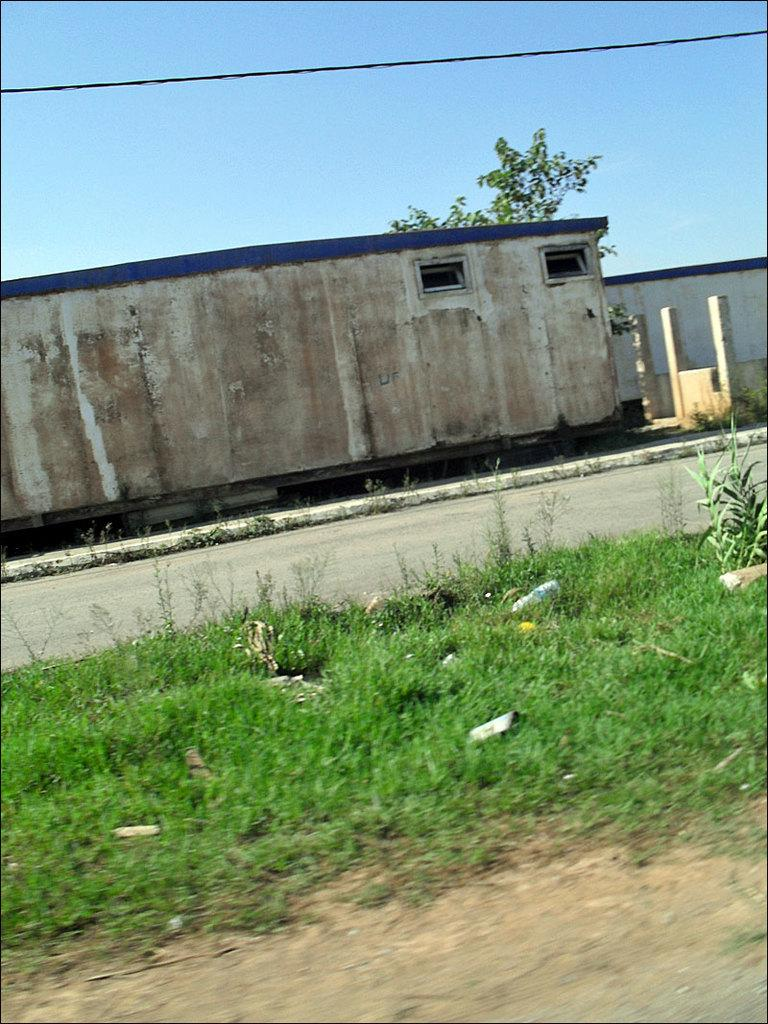What type of vegetation is present in the front of the image? There is grass on the land in the front of the image. What is located beside the grass? There is a road beside the grass. What can be seen in the background of the image? There is a building in the background of the image. What is behind the building? There is a tree behind the building. What is visible above the building? The sky is visible above the building. Where is the unit located in the image? There is no unit mentioned or visible in the image. What type of bucket can be seen in the image? There is no bucket present in the image. 